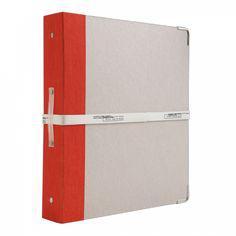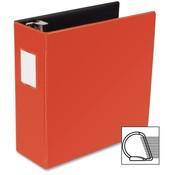The first image is the image on the left, the second image is the image on the right. Examine the images to the left and right. Is the description "One image shows four upright binders of different colors, and the other shows just one upright binder." accurate? Answer yes or no. No. The first image is the image on the left, the second image is the image on the right. Evaluate the accuracy of this statement regarding the images: "Five note books, all in different colors, are shown, four in one image all facing the same way, and one in the other image that has a white label on the spine.". Is it true? Answer yes or no. No. 